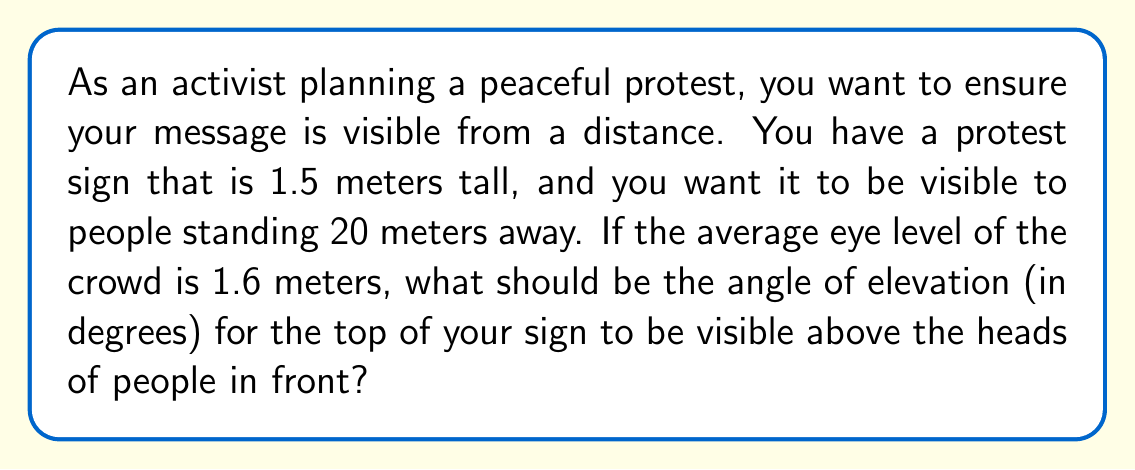Teach me how to tackle this problem. Let's approach this step-by-step:

1) First, let's visualize the scenario:

   [asy]
   import geometry;
   
   size(200);
   
   pair A = (0,0), B = (20,0), C = (0,1.6), D = (0,3.1);
   
   draw(A--B--C--A);
   draw(A--D);
   
   label("Ground", (10,-0.5), S);
   label("20 m", (10,0), S);
   label("1.6 m", (-0.5,0.8), W);
   label("1.5 m", (-0.5,2.35), W);
   label("$\theta$", (1,0.5), NE);
   
   dot(C);
   dot(D);
   
   [/asy]

2) We need to find the angle $\theta$ between the ground and the line of sight to the top of the sign.

3) We can use the tangent function to solve this:

   $\tan(\theta) = \frac{\text{opposite}}{\text{adjacent}}$

4) The opposite side is the height difference between the top of the sign and eye level:
   $1.5 + 1.6 - 1.6 = 1.5$ meters

5) The adjacent side is the distance to the viewers: 20 meters

6) Substituting into the tangent function:

   $\tan(\theta) = \frac{1.5}{20}$

7) To find $\theta$, we need to use the inverse tangent (arctan) function:

   $\theta = \arctan(\frac{1.5}{20})$

8) Calculate this value:

   $\theta = \arctan(0.075) \approx 4.29°$
Answer: $4.29°$ 